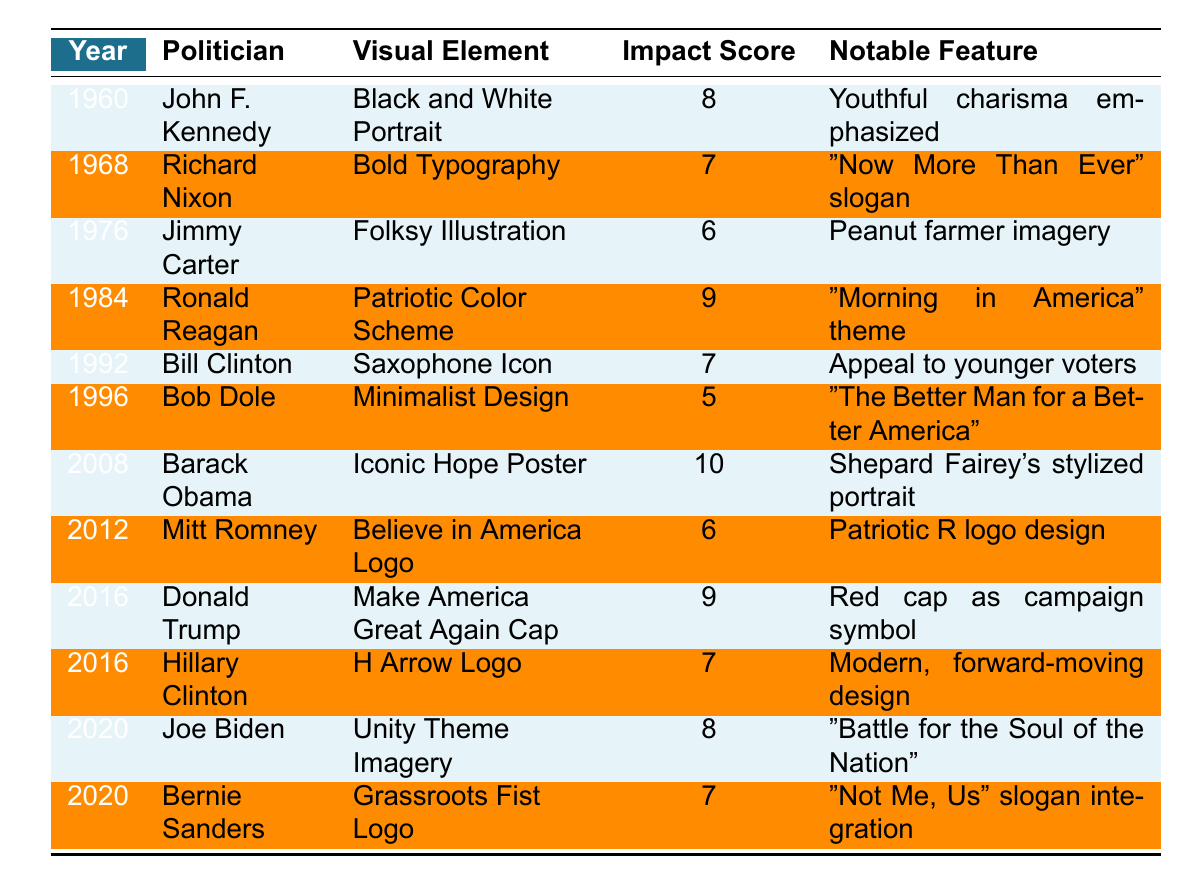What visual element was associated with Barack Obama's campaign in 2008? The table indicates that Barack Obama used the "Iconic Hope Poster" as his visual element in 2008.
Answer: Iconic Hope Poster Which politician had the highest impact score for their campaign visual element? According to the table, Barack Obama had the highest impact score of 10 for his "Iconic Hope Poster."
Answer: Barack Obama What notable feature is associated with Richard Nixon's 1968 campaign poster? The table states that Nixon's 1968 campaign utilized "Bold Typography" with the notable feature being the "Now More Than Ever" slogan.
Answer: "Now More Than Ever" slogan How many campaigns used a color scheme related to patriotism? By examining the table, Ronald Reagan (1984) and Mitt Romney (2012) both used elements related to patriotism; thus, there are two campaigns.
Answer: 2 What were the impact scores of the visual elements used in Joe Biden's and Bernie Sanders' campaigns in 2020? The table shows that Joe Biden's "Unity Theme Imagery" had an impact score of 8 and Bernie Sanders' "Grassroots Fist Logo" had an impact score of 7.
Answer: Biden: 8, Sanders: 7 Was the minimalistic design used by Bob Dole considered highly impactful? The impact score for Bob Dole’s "Minimalist Design" is listed as 5, indicating it was not highly impactful.
Answer: No What is the average impact score of all the visual elements used in the campaigns from 1960 to 2020? The total impact scores from the table are 8 + 7 + 6 + 9 + 7 + 5 + 10 + 6 + 9 + 7 + 8 + 7 = 81. There are 12 campaigns, so the average is 81/12 = 6.75.
Answer: 6.75 Which visual element trend signifies an appeal to younger voters in the 1992 campaign? The "Saxophone Icon" used by Bill Clinton is noted in the table with a notable feature that appeals to younger voters, reflecting a trend in that era.
Answer: Saxophone Icon Did any campaign use a logo as their primary visual element after 2000? Yes, the table indicates that both Mitt Romney (2012) with his "Believe in America Logo" and Hillary Clinton (2016) with her "H Arrow Logo" utilized logos as their primary visual elements.
Answer: Yes Which visual element had the notable feature of referencing a "Morning in America" theme and what was its impact score? The table states that Ronald Reagan's "Patriotic Color Scheme" had the notable feature of "Morning in America" and its impact score was 9.
Answer: Impact score: 9 